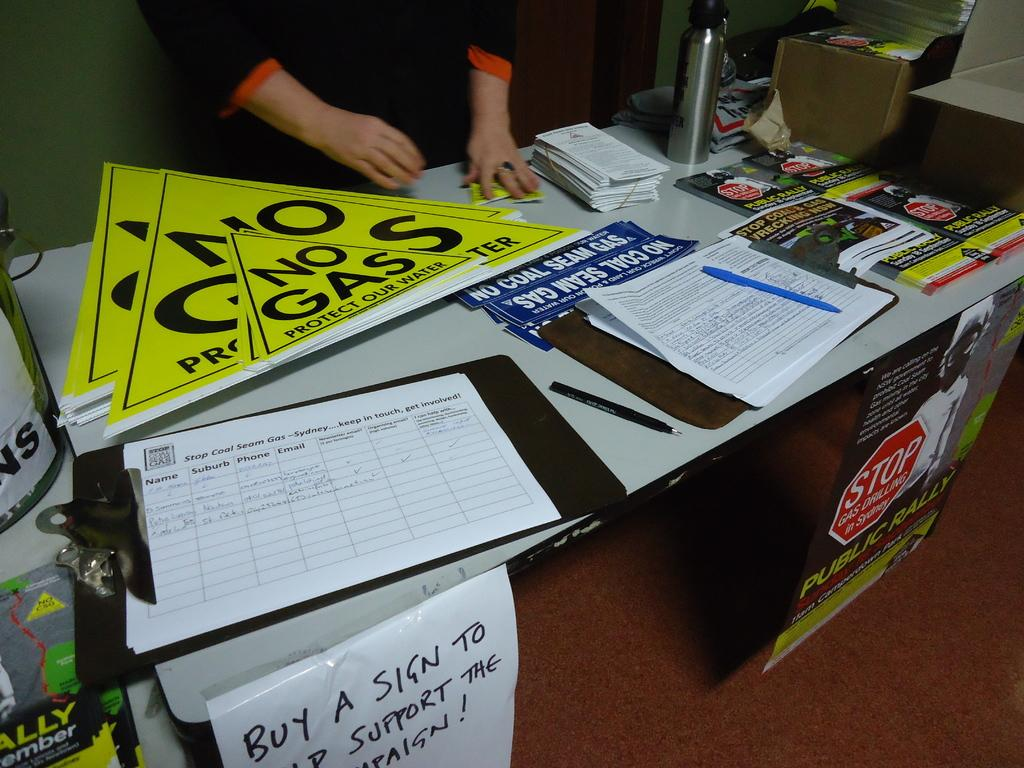<image>
Render a clear and concise summary of the photo. Sales of these No Gas signs support their campaign. 